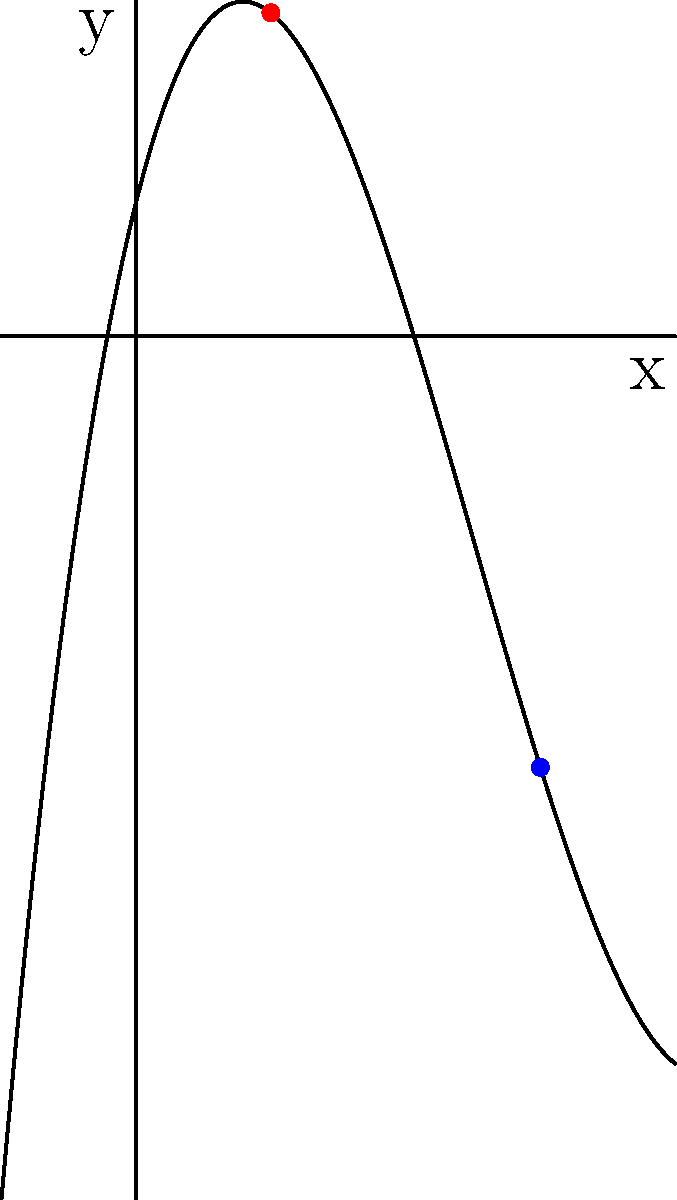The polynomial graph above represents the curvature of a wrought iron gate design. If the red dot indicates the inflection point and the blue dot represents the maximum height of the gate, what is the degree of the polynomial function describing this curve? To determine the degree of the polynomial function, we need to analyze the graph's behavior:

1. The curve has one inflection point (red dot), which indicates a change in concavity.
2. There is one local maximum (blue dot).
3. The graph appears to have no more than two turning points.
4. As x increases, the function seems to grow without bound.

These characteristics suggest a cubic polynomial function:

1. A cubic function ($ax^3 + bx^2 + cx + d$) is the lowest degree polynomial that can have both an inflection point and a local maximum/minimum.
2. The curve's behavior as x increases (growing without bound) is consistent with a positive leading coefficient for a cubic function.
3. A quadratic function would not have an inflection point, and a quartic or higher degree polynomial would typically have more complex behavior unless it's carefully constructed.

Therefore, based on the graph's features and the context of the wrought iron gate design, the polynomial function describing this curve is most likely of degree 3.
Answer: 3 